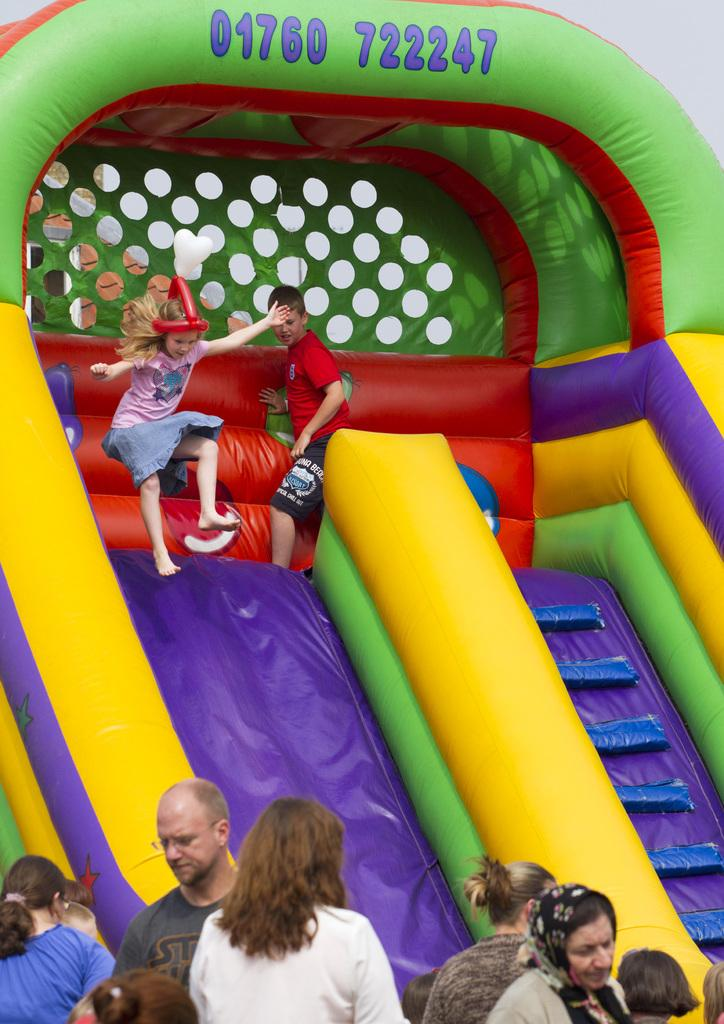Who is present in the image? There are people in the image. What are the kids doing in the image? Two kids are playing on a bouncy castle. What is unique about the bouncy castle? There are numbers on the bouncy castle. What channel is the girl watching on TV in the image? There is no girl or TV present in the image; it features people and a bouncy castle. 